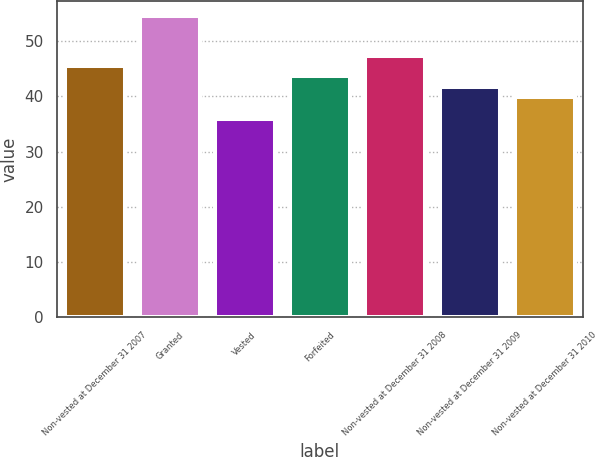Convert chart to OTSL. <chart><loc_0><loc_0><loc_500><loc_500><bar_chart><fcel>Non-vested at December 31 2007<fcel>Granted<fcel>Vested<fcel>Forfeited<fcel>Non-vested at December 31 2008<fcel>Non-vested at December 31 2009<fcel>Non-vested at December 31 2010<nl><fcel>45.5<fcel>54.56<fcel>35.82<fcel>43.63<fcel>47.37<fcel>41.76<fcel>39.89<nl></chart> 